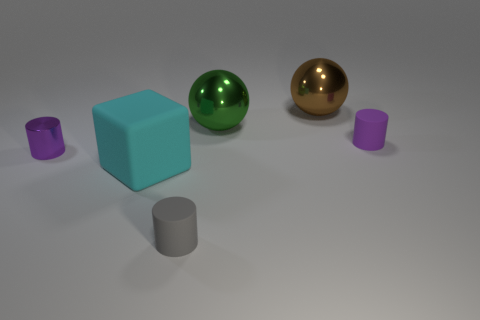Subtract all purple cylinders. How many cylinders are left? 1 Subtract all gray spheres. How many purple cylinders are left? 2 Add 1 red cylinders. How many objects exist? 7 Subtract all cubes. How many objects are left? 5 Subtract all brown cylinders. Subtract all blue blocks. How many cylinders are left? 3 Subtract all shiny objects. Subtract all big objects. How many objects are left? 0 Add 2 cylinders. How many cylinders are left? 5 Add 5 big green shiny cylinders. How many big green shiny cylinders exist? 5 Subtract 0 red cylinders. How many objects are left? 6 